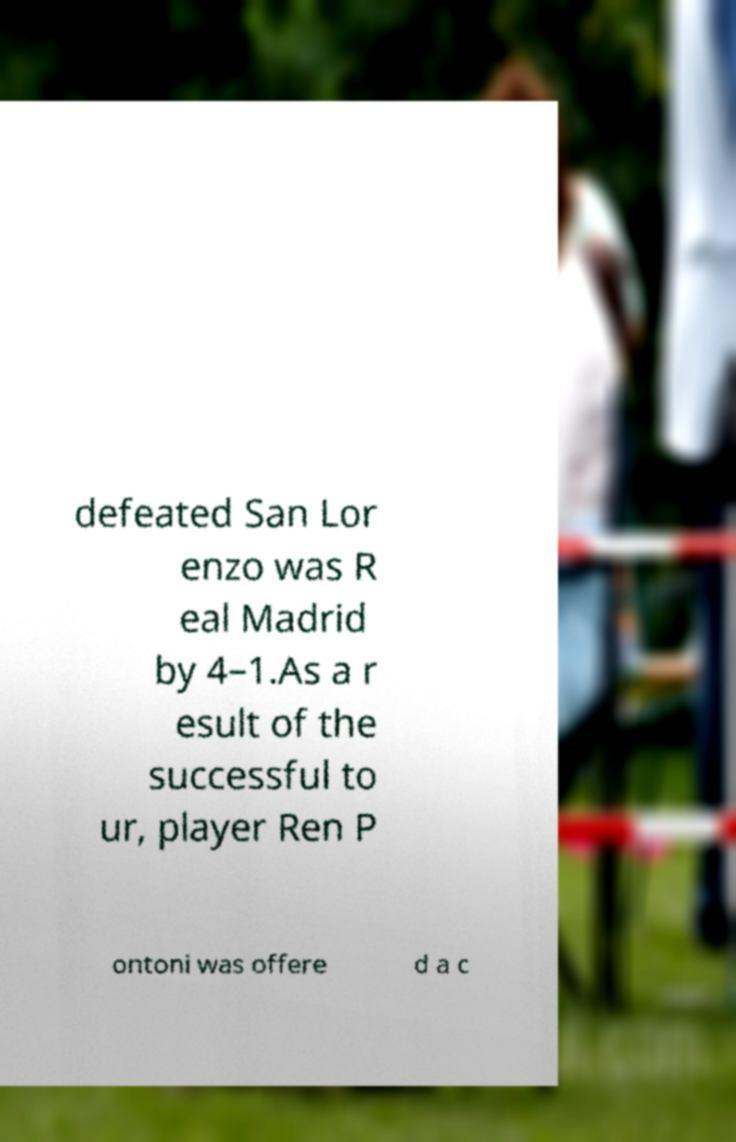Could you extract and type out the text from this image? defeated San Lor enzo was R eal Madrid by 4–1.As a r esult of the successful to ur, player Ren P ontoni was offere d a c 